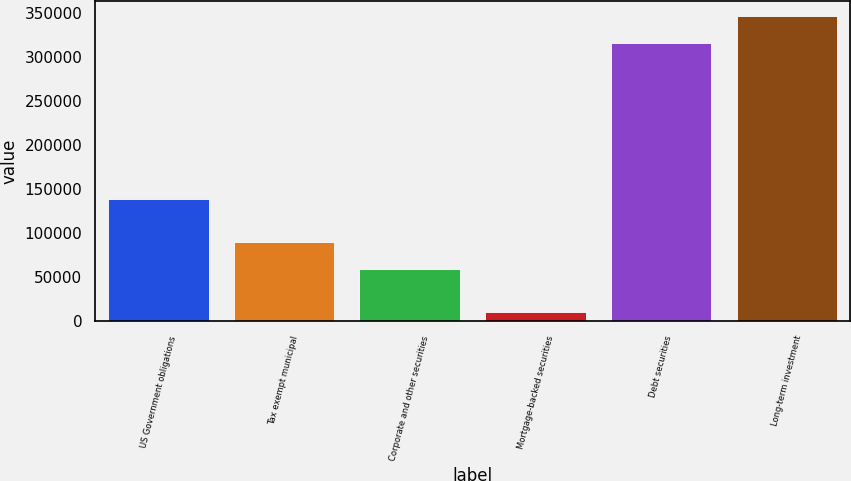Convert chart. <chart><loc_0><loc_0><loc_500><loc_500><bar_chart><fcel>US Government obligations<fcel>Tax exempt municipal<fcel>Corporate and other securities<fcel>Mortgage-backed securities<fcel>Debt securities<fcel>Long-term investment<nl><fcel>138943<fcel>89882<fcel>59088<fcel>11227<fcel>315528<fcel>346322<nl></chart> 